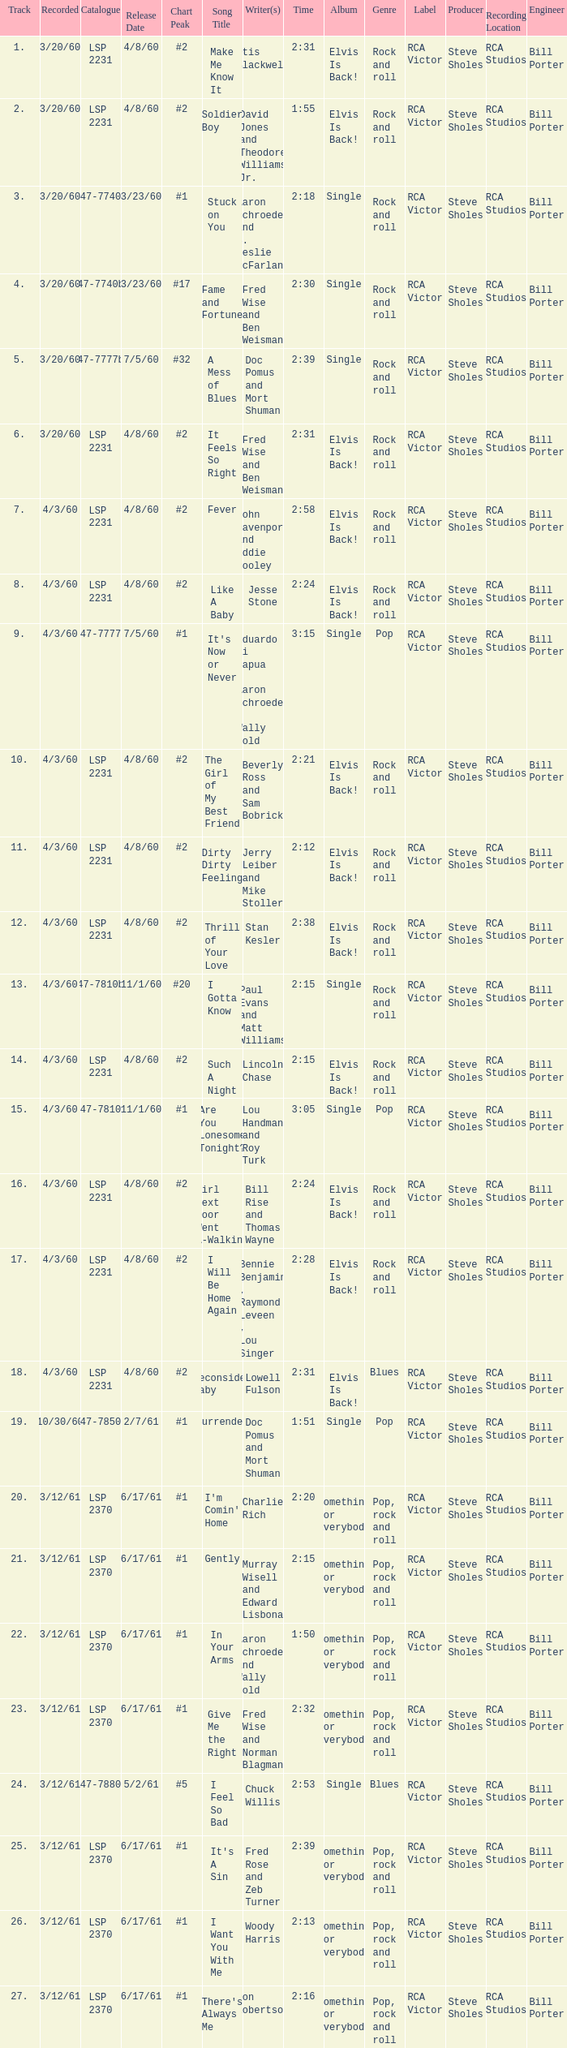Could you parse the entire table as a dict? {'header': ['Track', 'Recorded', 'Catalogue', 'Release Date', 'Chart Peak', 'Song Title', 'Writer(s)', 'Time', 'Album', 'Genre', 'Label', 'Producer', 'Recording Location', 'Engineer'], 'rows': [['1.', '3/20/60', 'LSP 2231', '4/8/60', '#2', 'Make Me Know It', 'Otis Blackwell', '2:31', 'Elvis Is Back!', 'Rock and roll', 'RCA Victor', 'Steve Sholes', 'RCA Studios', 'Bill Porter'], ['2.', '3/20/60', 'LSP 2231', '4/8/60', '#2', 'Soldier Boy', 'David Jones and Theodore Williams Jr.', '1:55', 'Elvis Is Back!', 'Rock and roll', 'RCA Victor', 'Steve Sholes', 'RCA Studios', 'Bill Porter'], ['3.', '3/20/60', '47-7740', '3/23/60', '#1', 'Stuck on You', 'Aaron Schroeder and S. Leslie McFarland', '2:18', 'Single', 'Rock and roll', 'RCA Victor', 'Steve Sholes', 'RCA Studios', 'Bill Porter'], ['4.', '3/20/60', '47-7740b', '3/23/60', '#17', 'Fame and Fortune', 'Fred Wise and Ben Weisman', '2:30', 'Single', 'Rock and roll', 'RCA Victor', 'Steve Sholes', 'RCA Studios', 'Bill Porter'], ['5.', '3/20/60', '47-7777b', '7/5/60', '#32', 'A Mess of Blues', 'Doc Pomus and Mort Shuman', '2:39', 'Single', 'Rock and roll', 'RCA Victor', 'Steve Sholes', 'RCA Studios', 'Bill Porter'], ['6.', '3/20/60', 'LSP 2231', '4/8/60', '#2', 'It Feels So Right', 'Fred Wise and Ben Weisman', '2:31', 'Elvis Is Back!', 'Rock and roll', 'RCA Victor', 'Steve Sholes', 'RCA Studios', 'Bill Porter'], ['7.', '4/3/60', 'LSP 2231', '4/8/60', '#2', 'Fever', 'John Davenport and Eddie Cooley', '2:58', 'Elvis Is Back!', 'Rock and roll', 'RCA Victor', 'Steve Sholes', 'RCA Studios', 'Bill Porter'], ['8.', '4/3/60', 'LSP 2231', '4/8/60', '#2', 'Like A Baby', 'Jesse Stone', '2:24', 'Elvis Is Back!', 'Rock and roll', 'RCA Victor', 'Steve Sholes', 'RCA Studios', 'Bill Porter'], ['9.', '4/3/60', '47-7777', '7/5/60', '#1', "It's Now or Never", 'Eduardo di Capua , Aaron Schroeder , Wally Gold', '3:15', 'Single', 'Pop', 'RCA Victor', 'Steve Sholes', 'RCA Studios', 'Bill Porter'], ['10.', '4/3/60', 'LSP 2231', '4/8/60', '#2', 'The Girl of My Best Friend', 'Beverly Ross and Sam Bobrick', '2:21', 'Elvis Is Back!', 'Rock and roll', 'RCA Victor', 'Steve Sholes', 'RCA Studios', 'Bill Porter'], ['11.', '4/3/60', 'LSP 2231', '4/8/60', '#2', 'Dirty Dirty Feeling', 'Jerry Leiber and Mike Stoller', '2:12', 'Elvis Is Back!', 'Rock and roll', 'RCA Victor', 'Steve Sholes', 'RCA Studios', 'Bill Porter'], ['12.', '4/3/60', 'LSP 2231', '4/8/60', '#2', 'Thrill of Your Love', 'Stan Kesler', '2:38', 'Elvis Is Back!', 'Rock and roll', 'RCA Victor', 'Steve Sholes', 'RCA Studios', 'Bill Porter'], ['13.', '4/3/60', '47-7810b', '11/1/60', '#20', 'I Gotta Know', 'Paul Evans and Matt Williams', '2:15', 'Single', 'Rock and roll', 'RCA Victor', 'Steve Sholes', 'RCA Studios', 'Bill Porter'], ['14.', '4/3/60', 'LSP 2231', '4/8/60', '#2', 'Such A Night', 'Lincoln Chase', '2:15', 'Elvis Is Back!', 'Rock and roll', 'RCA Victor', 'Steve Sholes', 'RCA Studios', 'Bill Porter'], ['15.', '4/3/60', '47-7810', '11/1/60', '#1', 'Are You Lonesome Tonight?', 'Lou Handman and Roy Turk', '3:05', 'Single', 'Pop', 'RCA Victor', 'Steve Sholes', 'RCA Studios', 'Bill Porter'], ['16.', '4/3/60', 'LSP 2231', '4/8/60', '#2', 'Girl Next Door Went A-Walking', 'Bill Rise and Thomas Wayne', '2:24', 'Elvis Is Back!', 'Rock and roll', 'RCA Victor', 'Steve Sholes', 'RCA Studios', 'Bill Porter'], ['17.', '4/3/60', 'LSP 2231', '4/8/60', '#2', 'I Will Be Home Again', 'Bennie Benjamin , Raymond Leveen , Lou Singer', '2:28', 'Elvis Is Back!', 'Rock and roll', 'RCA Victor', 'Steve Sholes', 'RCA Studios', 'Bill Porter'], ['18.', '4/3/60', 'LSP 2231', '4/8/60', '#2', 'Reconsider Baby', 'Lowell Fulson', '2:31', 'Elvis Is Back!', 'Blues', 'RCA Victor', 'Steve Sholes', 'RCA Studios', 'Bill Porter'], ['19.', '10/30/60', '47-7850', '2/7/61', '#1', 'Surrender', 'Doc Pomus and Mort Shuman', '1:51', 'Single', 'Pop', 'RCA Victor', 'Steve Sholes', 'RCA Studios', 'Bill Porter'], ['20.', '3/12/61', 'LSP 2370', '6/17/61', '#1', "I'm Comin' Home", 'Charlie Rich', '2:20', 'Something for Everybody', 'Pop, rock and roll', 'RCA Victor', 'Steve Sholes', 'RCA Studios', 'Bill Porter'], ['21.', '3/12/61', 'LSP 2370', '6/17/61', '#1', 'Gently', 'Murray Wisell and Edward Lisbona', '2:15', 'Something for Everybody', 'Pop, rock and roll', 'RCA Victor', 'Steve Sholes', 'RCA Studios', 'Bill Porter'], ['22.', '3/12/61', 'LSP 2370', '6/17/61', '#1', 'In Your Arms', 'Aaron Schroeder and Wally Gold', '1:50', 'Something for Everybody', 'Pop, rock and roll', 'RCA Victor', 'Steve Sholes', 'RCA Studios', 'Bill Porter'], ['23.', '3/12/61', 'LSP 2370', '6/17/61', '#1', 'Give Me the Right', 'Fred Wise and Norman Blagman', '2:32', 'Something for Everybody', 'Pop, rock and roll', 'RCA Victor', 'Steve Sholes', 'RCA Studios', 'Bill Porter'], ['24.', '3/12/61', '47-7880', '5/2/61', '#5', 'I Feel So Bad', 'Chuck Willis', '2:53', 'Single', 'Blues', 'RCA Victor', 'Steve Sholes', 'RCA Studios', 'Bill Porter'], ['25.', '3/12/61', 'LSP 2370', '6/17/61', '#1', "It's A Sin", 'Fred Rose and Zeb Turner', '2:39', 'Something for Everybody', 'Pop, rock and roll', 'RCA Victor', 'Steve Sholes', 'RCA Studios', 'Bill Porter'], ['26.', '3/12/61', 'LSP 2370', '6/17/61', '#1', 'I Want You With Me', 'Woody Harris', '2:13', 'Something for Everybody', 'Pop, rock and roll', 'RCA Victor', 'Steve Sholes', 'RCA Studios', 'Bill Porter'], ['27.', '3/12/61', 'LSP 2370', '6/17/61', '#1', "There's Always Me", 'Don Robertson', '2:16', 'Something for Everybody', 'Pop, rock and roll', 'RCA Victor', 'Steve Sholes', 'RCA Studios', 'Bill Porter']]} What is the time of songs that have the writer Aaron Schroeder and Wally Gold? 1:50. 